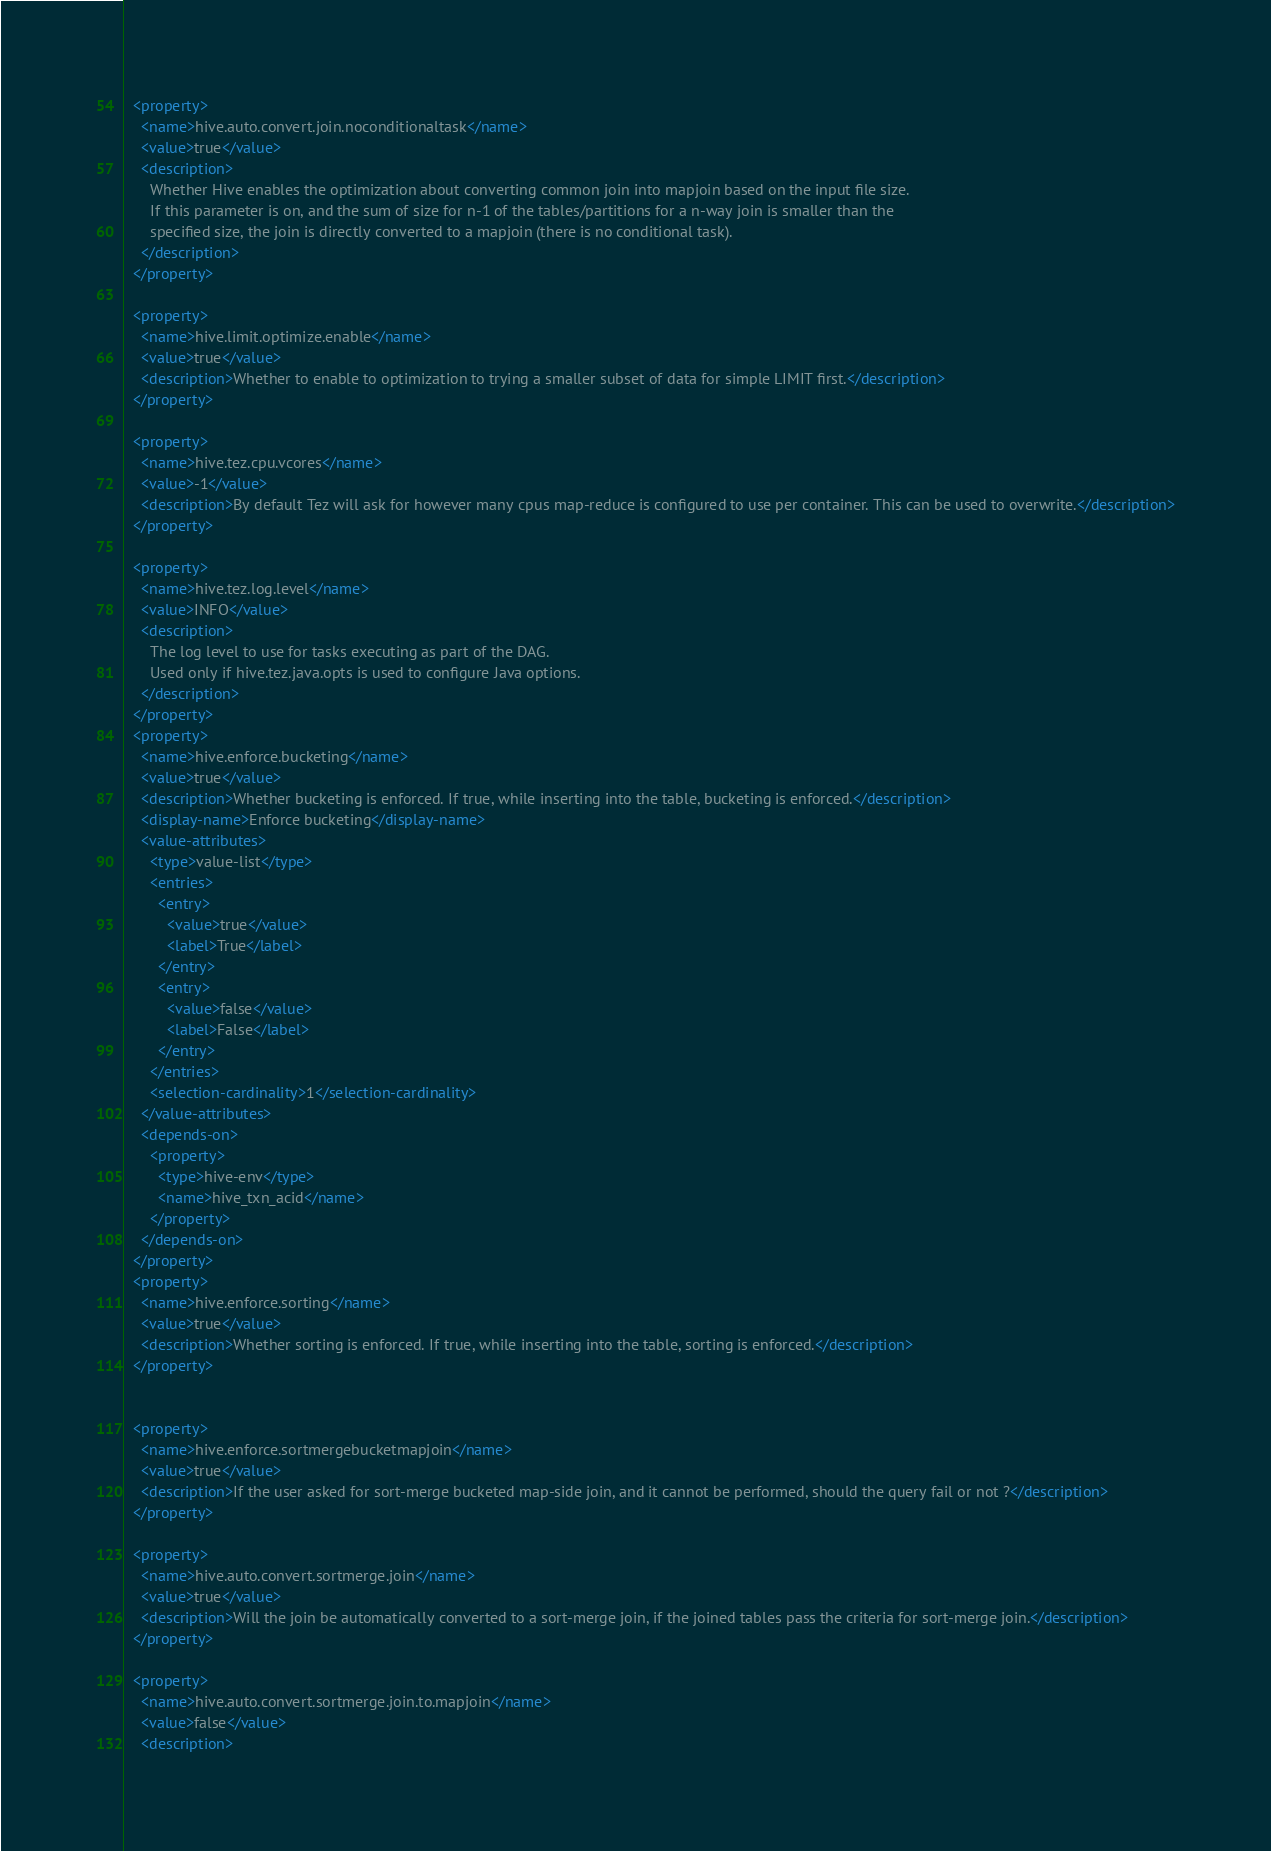<code> <loc_0><loc_0><loc_500><loc_500><_XML_>  <property>
    <name>hive.auto.convert.join.noconditionaltask</name>
    <value>true</value>
    <description>
      Whether Hive enables the optimization about converting common join into mapjoin based on the input file size.
      If this parameter is on, and the sum of size for n-1 of the tables/partitions for a n-way join is smaller than the
      specified size, the join is directly converted to a mapjoin (there is no conditional task).
    </description>
  </property>

  <property>
    <name>hive.limit.optimize.enable</name>
    <value>true</value>
    <description>Whether to enable to optimization to trying a smaller subset of data for simple LIMIT first.</description>
  </property>

  <property>
    <name>hive.tez.cpu.vcores</name>
    <value>-1</value>
    <description>By default Tez will ask for however many cpus map-reduce is configured to use per container. This can be used to overwrite.</description>
  </property>

  <property>
    <name>hive.tez.log.level</name>
    <value>INFO</value>
    <description>
      The log level to use for tasks executing as part of the DAG.
      Used only if hive.tez.java.opts is used to configure Java options.
    </description>
  </property>
  <property>
    <name>hive.enforce.bucketing</name>
    <value>true</value>
    <description>Whether bucketing is enforced. If true, while inserting into the table, bucketing is enforced.</description>
    <display-name>Enforce bucketing</display-name>
    <value-attributes>
      <type>value-list</type>
      <entries>
        <entry>
          <value>true</value>
          <label>True</label>
        </entry>
        <entry>
          <value>false</value>
          <label>False</label>
        </entry>
      </entries>
      <selection-cardinality>1</selection-cardinality>
    </value-attributes>
    <depends-on>
      <property>
        <type>hive-env</type>
        <name>hive_txn_acid</name>
      </property>
    </depends-on>
  </property>
  <property>
    <name>hive.enforce.sorting</name>
    <value>true</value>
    <description>Whether sorting is enforced. If true, while inserting into the table, sorting is enforced.</description>
  </property>


  <property>
    <name>hive.enforce.sortmergebucketmapjoin</name>
    <value>true</value>
    <description>If the user asked for sort-merge bucketed map-side join, and it cannot be performed, should the query fail or not ?</description>
  </property>

  <property>
    <name>hive.auto.convert.sortmerge.join</name>
    <value>true</value>
    <description>Will the join be automatically converted to a sort-merge join, if the joined tables pass the criteria for sort-merge join.</description>
  </property>

  <property>
    <name>hive.auto.convert.sortmerge.join.to.mapjoin</name>
    <value>false</value>
    <description></code> 